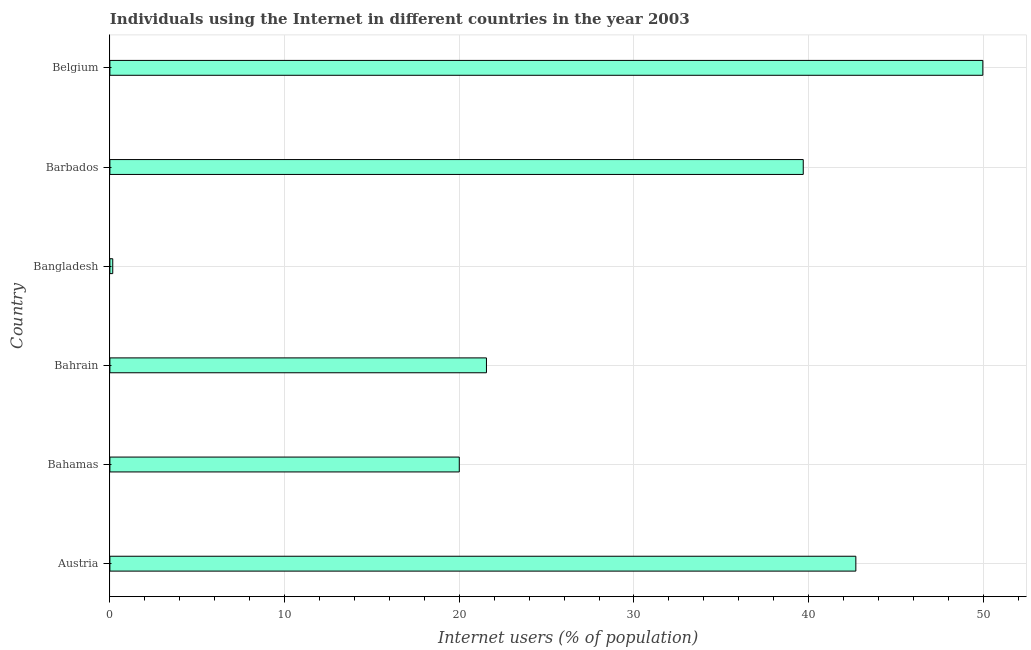What is the title of the graph?
Provide a succinct answer. Individuals using the Internet in different countries in the year 2003. What is the label or title of the X-axis?
Provide a succinct answer. Internet users (% of population). What is the label or title of the Y-axis?
Provide a succinct answer. Country. What is the number of internet users in Austria?
Make the answer very short. 42.7. Across all countries, what is the maximum number of internet users?
Offer a very short reply. 49.97. Across all countries, what is the minimum number of internet users?
Offer a terse response. 0.16. In which country was the number of internet users minimum?
Provide a succinct answer. Bangladesh. What is the sum of the number of internet users?
Ensure brevity in your answer.  174.08. What is the difference between the number of internet users in Barbados and Belgium?
Offer a terse response. -10.28. What is the average number of internet users per country?
Give a very brief answer. 29.01. What is the median number of internet users?
Offer a very short reply. 30.62. In how many countries, is the number of internet users greater than 28 %?
Make the answer very short. 3. What is the ratio of the number of internet users in Bahamas to that in Bangladesh?
Provide a short and direct response. 122.04. What is the difference between the highest and the second highest number of internet users?
Offer a very short reply. 7.27. Is the sum of the number of internet users in Bahrain and Bangladesh greater than the maximum number of internet users across all countries?
Your answer should be compact. No. What is the difference between the highest and the lowest number of internet users?
Provide a succinct answer. 49.81. How many bars are there?
Your answer should be compact. 6. Are all the bars in the graph horizontal?
Provide a short and direct response. Yes. What is the difference between two consecutive major ticks on the X-axis?
Keep it short and to the point. 10. What is the Internet users (% of population) in Austria?
Make the answer very short. 42.7. What is the Internet users (% of population) of Bahrain?
Your answer should be compact. 21.55. What is the Internet users (% of population) of Bangladesh?
Ensure brevity in your answer.  0.16. What is the Internet users (% of population) in Barbados?
Keep it short and to the point. 39.69. What is the Internet users (% of population) of Belgium?
Provide a succinct answer. 49.97. What is the difference between the Internet users (% of population) in Austria and Bahamas?
Ensure brevity in your answer.  22.7. What is the difference between the Internet users (% of population) in Austria and Bahrain?
Give a very brief answer. 21.15. What is the difference between the Internet users (% of population) in Austria and Bangladesh?
Offer a very short reply. 42.54. What is the difference between the Internet users (% of population) in Austria and Barbados?
Give a very brief answer. 3.01. What is the difference between the Internet users (% of population) in Austria and Belgium?
Give a very brief answer. -7.27. What is the difference between the Internet users (% of population) in Bahamas and Bahrain?
Your answer should be compact. -1.55. What is the difference between the Internet users (% of population) in Bahamas and Bangladesh?
Provide a succinct answer. 19.84. What is the difference between the Internet users (% of population) in Bahamas and Barbados?
Your response must be concise. -19.69. What is the difference between the Internet users (% of population) in Bahamas and Belgium?
Keep it short and to the point. -29.97. What is the difference between the Internet users (% of population) in Bahrain and Bangladesh?
Give a very brief answer. 21.39. What is the difference between the Internet users (% of population) in Bahrain and Barbados?
Offer a very short reply. -18.13. What is the difference between the Internet users (% of population) in Bahrain and Belgium?
Provide a succinct answer. -28.42. What is the difference between the Internet users (% of population) in Bangladesh and Barbados?
Make the answer very short. -39.53. What is the difference between the Internet users (% of population) in Bangladesh and Belgium?
Keep it short and to the point. -49.81. What is the difference between the Internet users (% of population) in Barbados and Belgium?
Provide a succinct answer. -10.28. What is the ratio of the Internet users (% of population) in Austria to that in Bahamas?
Offer a terse response. 2.13. What is the ratio of the Internet users (% of population) in Austria to that in Bahrain?
Your answer should be very brief. 1.98. What is the ratio of the Internet users (% of population) in Austria to that in Bangladesh?
Make the answer very short. 260.56. What is the ratio of the Internet users (% of population) in Austria to that in Barbados?
Provide a succinct answer. 1.08. What is the ratio of the Internet users (% of population) in Austria to that in Belgium?
Provide a succinct answer. 0.85. What is the ratio of the Internet users (% of population) in Bahamas to that in Bahrain?
Provide a succinct answer. 0.93. What is the ratio of the Internet users (% of population) in Bahamas to that in Bangladesh?
Offer a very short reply. 122.04. What is the ratio of the Internet users (% of population) in Bahamas to that in Barbados?
Provide a short and direct response. 0.5. What is the ratio of the Internet users (% of population) in Bahrain to that in Bangladesh?
Give a very brief answer. 131.53. What is the ratio of the Internet users (% of population) in Bahrain to that in Barbados?
Provide a succinct answer. 0.54. What is the ratio of the Internet users (% of population) in Bahrain to that in Belgium?
Give a very brief answer. 0.43. What is the ratio of the Internet users (% of population) in Bangladesh to that in Barbados?
Give a very brief answer. 0. What is the ratio of the Internet users (% of population) in Bangladesh to that in Belgium?
Keep it short and to the point. 0. What is the ratio of the Internet users (% of population) in Barbados to that in Belgium?
Provide a short and direct response. 0.79. 